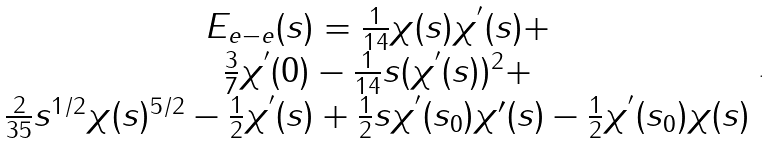<formula> <loc_0><loc_0><loc_500><loc_500>\begin{array} { c c } E _ { e - e } ( s ) = \frac { 1 } { 1 4 } \chi ( s ) \chi ^ { ^ { \prime } } ( s ) + \\ \frac { 3 } { 7 } \chi ^ { ^ { \prime } } ( 0 ) - \frac { 1 } { 1 4 } s ( \chi ^ { ^ { \prime } } ( s ) ) ^ { 2 } + \\ \frac { 2 } { 3 5 } s ^ { 1 / 2 } \chi ( s ) ^ { 5 / 2 } - \frac { 1 } { 2 } \chi ^ { ^ { \prime } } ( s ) + \frac { 1 } { 2 } s \chi ^ { ^ { \prime } } ( s _ { 0 } ) \chi { ^ { \prime } } ( s ) - \frac { 1 } { 2 } \chi ^ { ^ { \prime } } ( s _ { 0 } ) \chi ( s ) \end{array} .</formula> 